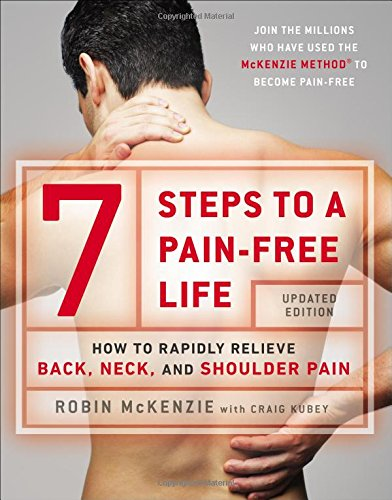Who collaborated with Robin McKenzie on this book? Robin McKenzie collaborated with Craig Kubey in authoring this book, who helped in distilling the McKenzie Method into an accessible format for a broader audience. 